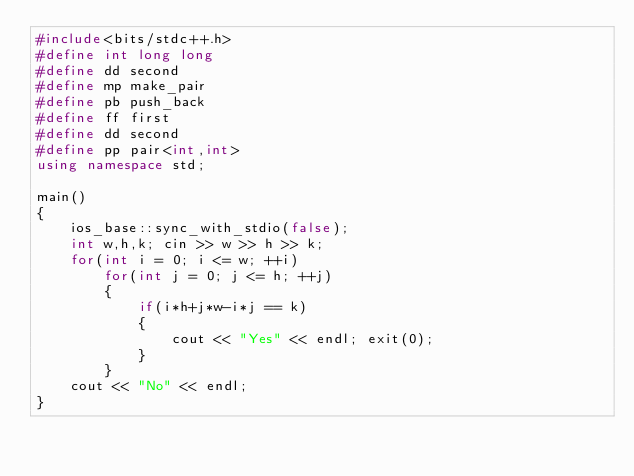Convert code to text. <code><loc_0><loc_0><loc_500><loc_500><_C++_>#include<bits/stdc++.h>
#define int long long
#define dd second
#define mp make_pair
#define pb push_back
#define ff first
#define dd second
#define pp pair<int,int>
using namespace std;

main()
{
    ios_base::sync_with_stdio(false);
    int w,h,k; cin >> w >> h >> k;
    for(int i = 0; i <= w; ++i)
        for(int j = 0; j <= h; ++j)
        {
            if(i*h+j*w-i*j == k)
            {
                cout << "Yes" << endl; exit(0);
            }
        }
    cout << "No" << endl;
}

</code> 